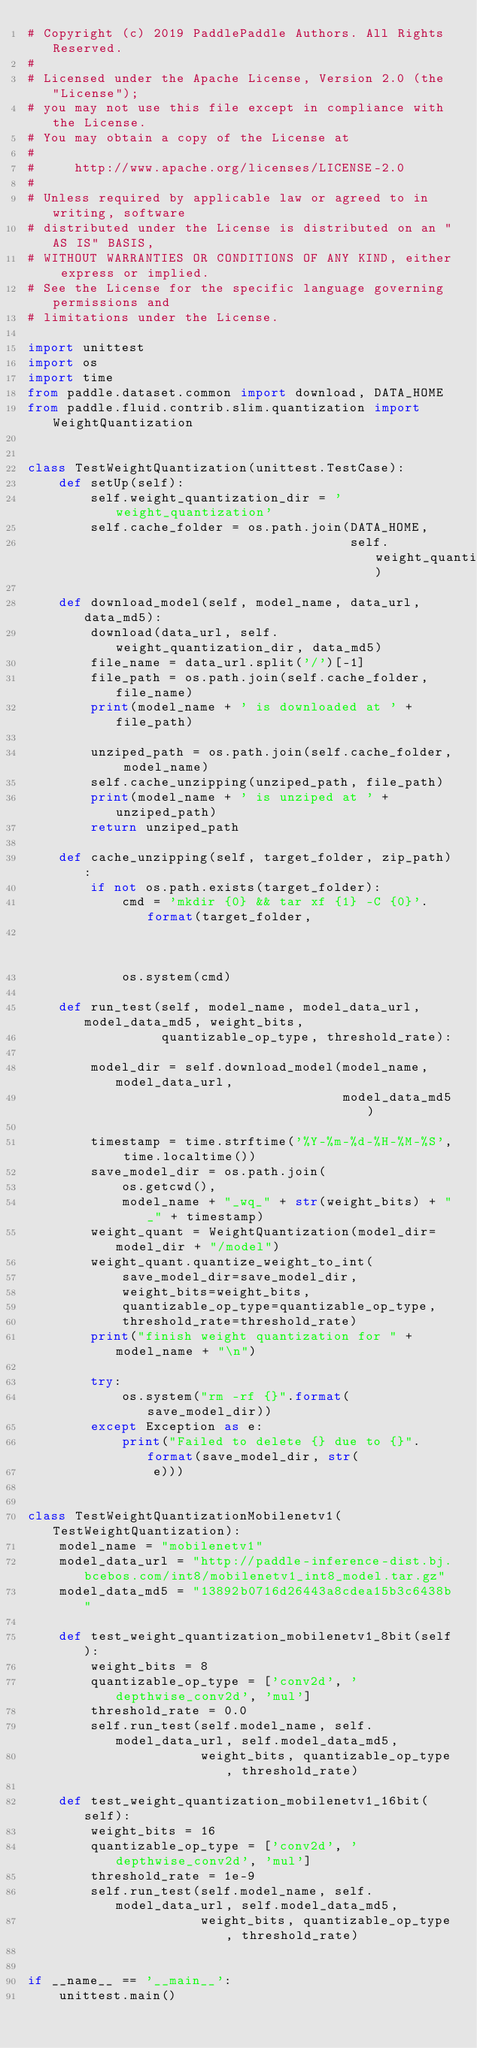<code> <loc_0><loc_0><loc_500><loc_500><_Python_># Copyright (c) 2019 PaddlePaddle Authors. All Rights Reserved.
#
# Licensed under the Apache License, Version 2.0 (the "License");
# you may not use this file except in compliance with the License.
# You may obtain a copy of the License at
#
#     http://www.apache.org/licenses/LICENSE-2.0
#
# Unless required by applicable law or agreed to in writing, software
# distributed under the License is distributed on an "AS IS" BASIS,
# WITHOUT WARRANTIES OR CONDITIONS OF ANY KIND, either express or implied.
# See the License for the specific language governing permissions and
# limitations under the License.

import unittest
import os
import time
from paddle.dataset.common import download, DATA_HOME
from paddle.fluid.contrib.slim.quantization import WeightQuantization


class TestWeightQuantization(unittest.TestCase):
    def setUp(self):
        self.weight_quantization_dir = 'weight_quantization'
        self.cache_folder = os.path.join(DATA_HOME,
                                         self.weight_quantization_dir)

    def download_model(self, model_name, data_url, data_md5):
        download(data_url, self.weight_quantization_dir, data_md5)
        file_name = data_url.split('/')[-1]
        file_path = os.path.join(self.cache_folder, file_name)
        print(model_name + ' is downloaded at ' + file_path)

        unziped_path = os.path.join(self.cache_folder, model_name)
        self.cache_unzipping(unziped_path, file_path)
        print(model_name + ' is unziped at ' + unziped_path)
        return unziped_path

    def cache_unzipping(self, target_folder, zip_path):
        if not os.path.exists(target_folder):
            cmd = 'mkdir {0} && tar xf {1} -C {0}'.format(target_folder,
                                                          zip_path)
            os.system(cmd)

    def run_test(self, model_name, model_data_url, model_data_md5, weight_bits,
                 quantizable_op_type, threshold_rate):

        model_dir = self.download_model(model_name, model_data_url,
                                        model_data_md5)

        timestamp = time.strftime('%Y-%m-%d-%H-%M-%S', time.localtime())
        save_model_dir = os.path.join(
            os.getcwd(),
            model_name + "_wq_" + str(weight_bits) + "_" + timestamp)
        weight_quant = WeightQuantization(model_dir=model_dir + "/model")
        weight_quant.quantize_weight_to_int(
            save_model_dir=save_model_dir,
            weight_bits=weight_bits,
            quantizable_op_type=quantizable_op_type,
            threshold_rate=threshold_rate)
        print("finish weight quantization for " + model_name + "\n")

        try:
            os.system("rm -rf {}".format(save_model_dir))
        except Exception as e:
            print("Failed to delete {} due to {}".format(save_model_dir, str(
                e)))


class TestWeightQuantizationMobilenetv1(TestWeightQuantization):
    model_name = "mobilenetv1"
    model_data_url = "http://paddle-inference-dist.bj.bcebos.com/int8/mobilenetv1_int8_model.tar.gz"
    model_data_md5 = "13892b0716d26443a8cdea15b3c6438b"

    def test_weight_quantization_mobilenetv1_8bit(self):
        weight_bits = 8
        quantizable_op_type = ['conv2d', 'depthwise_conv2d', 'mul']
        threshold_rate = 0.0
        self.run_test(self.model_name, self.model_data_url, self.model_data_md5,
                      weight_bits, quantizable_op_type, threshold_rate)

    def test_weight_quantization_mobilenetv1_16bit(self):
        weight_bits = 16
        quantizable_op_type = ['conv2d', 'depthwise_conv2d', 'mul']
        threshold_rate = 1e-9
        self.run_test(self.model_name, self.model_data_url, self.model_data_md5,
                      weight_bits, quantizable_op_type, threshold_rate)


if __name__ == '__main__':
    unittest.main()
</code> 